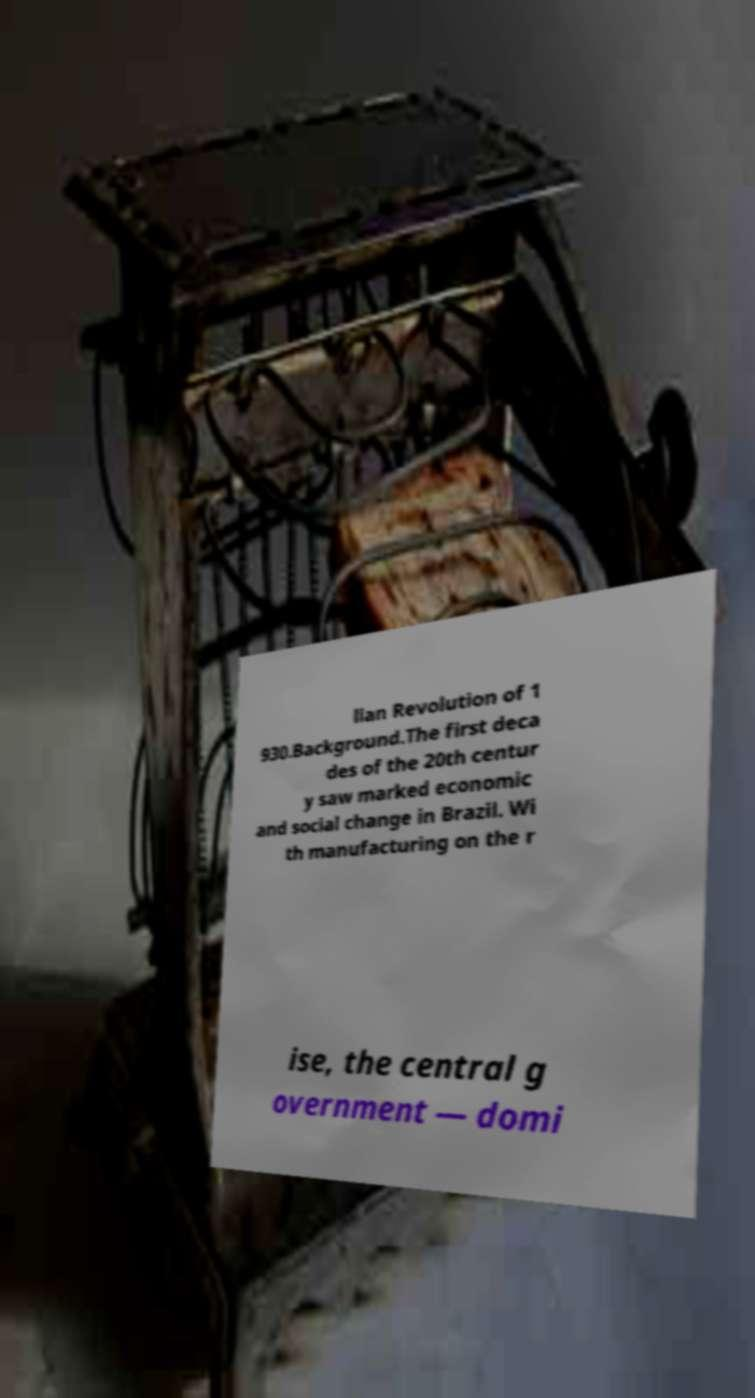Please identify and transcribe the text found in this image. lian Revolution of 1 930.Background.The first deca des of the 20th centur y saw marked economic and social change in Brazil. Wi th manufacturing on the r ise, the central g overnment — domi 